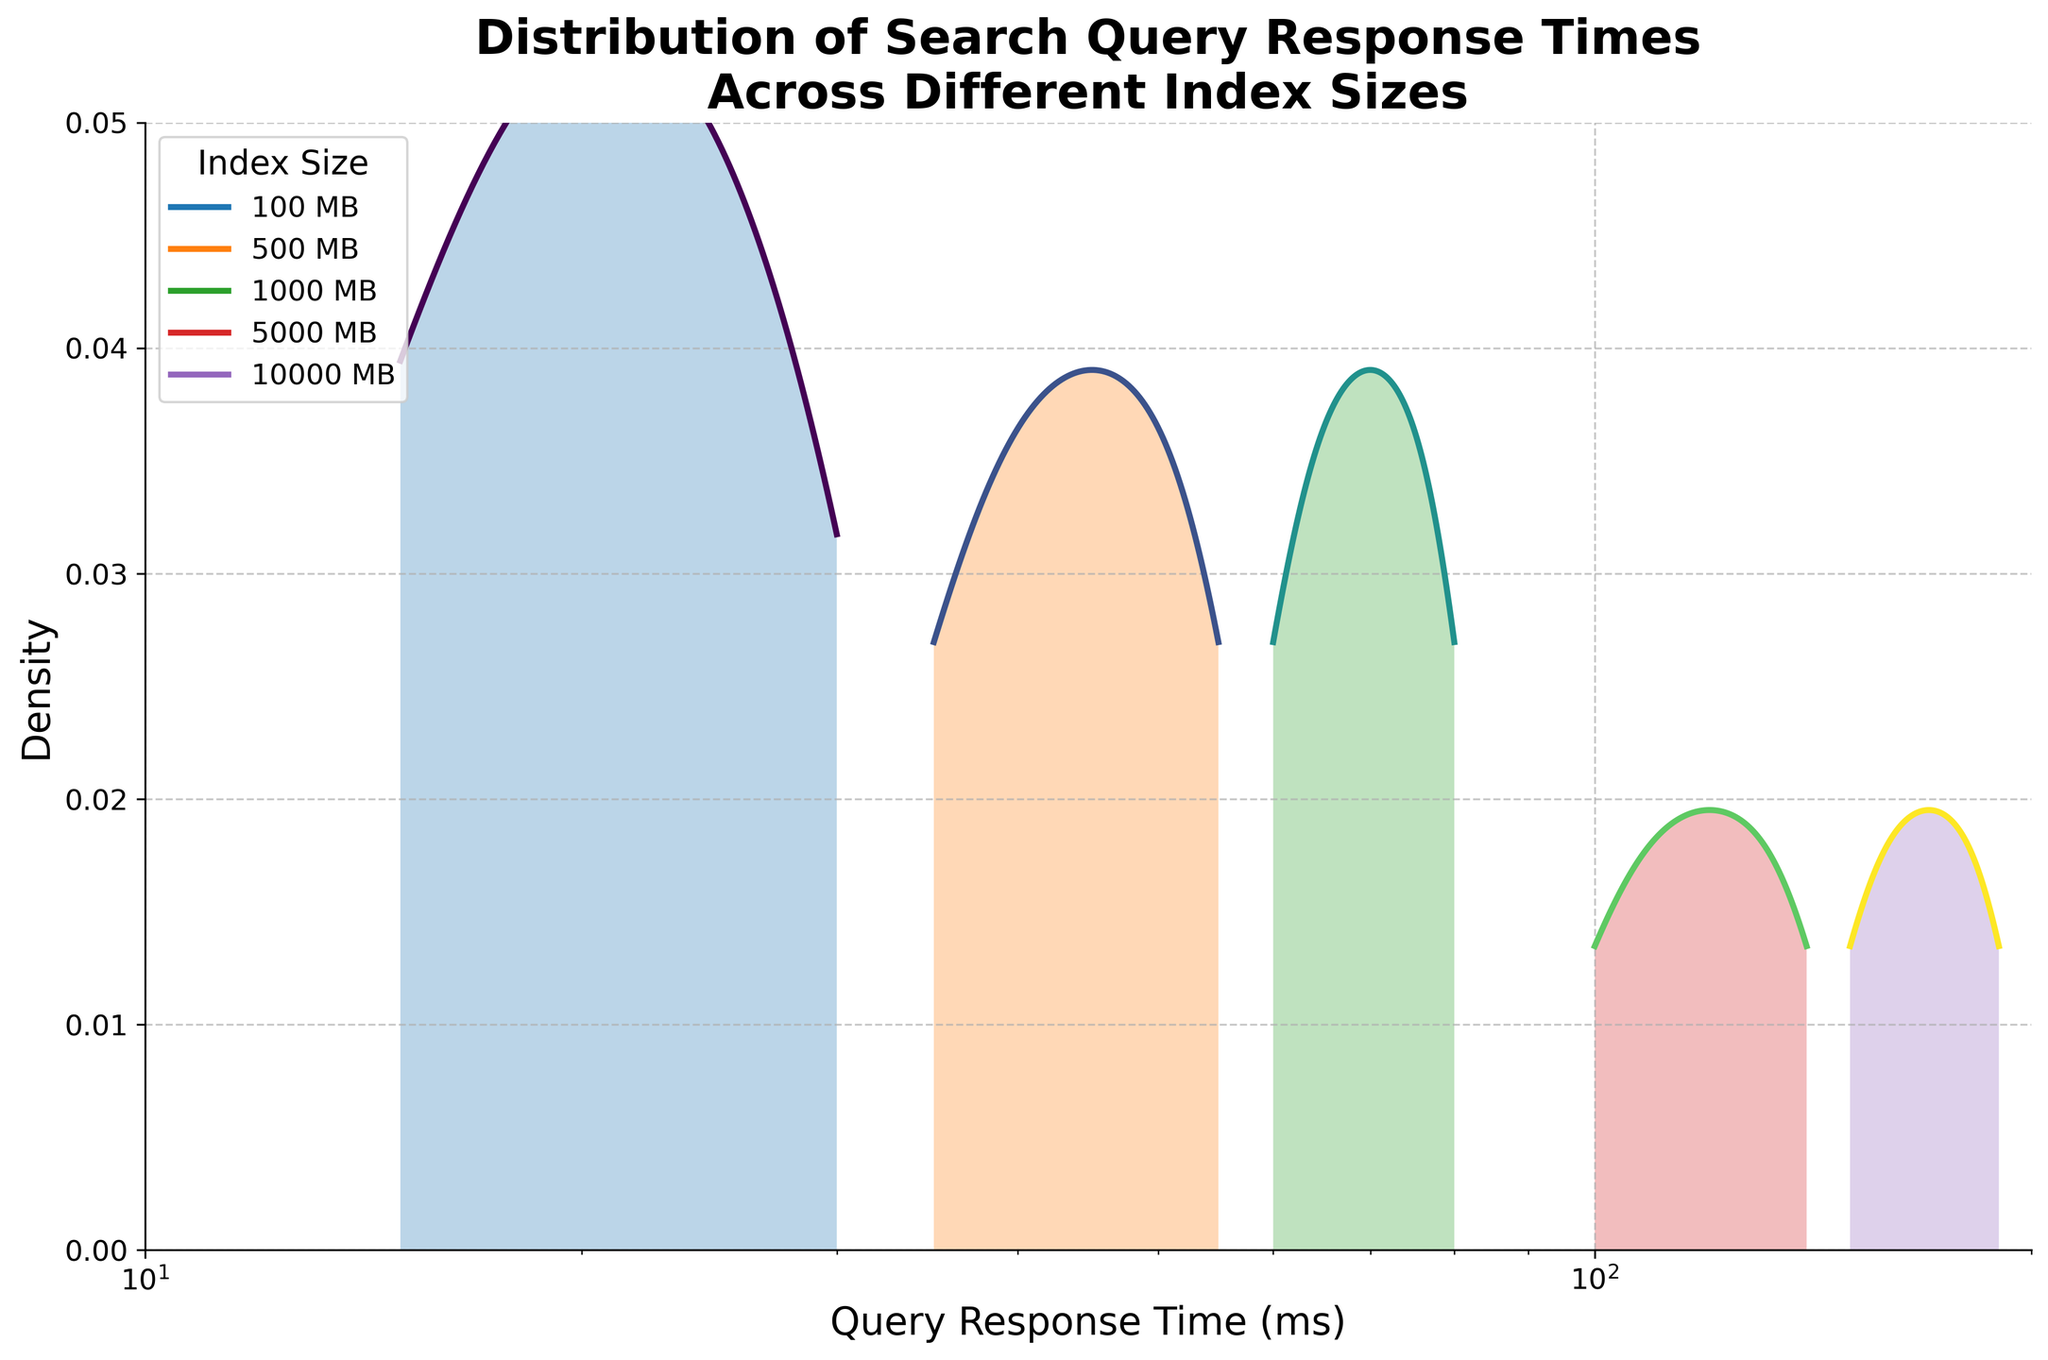What is the title of the density plot? The title is prominently displayed at the top of the density plot and reads "Distribution of Search Query Response Times Across Different Index Sizes."
Answer: Distribution of Search Query Response Times Across Different Index Sizes What is the range of the x-axis? The x-axis range can be observed from the minimum and maximum values shown, which are 10 and 200 respectively.
Answer: 10 to 200 Which index size has the highest density peak? By analyzing the plotted density lines, the 100 MB index size has the highest peak within the range of query response times.
Answer: 100 MB What happens to the density peaks as the index size increases? Observing the density plot, you can see that as the index size increases, the density peaks shift to higher response times, indicating that larger indexes generally have higher response times.
Answer: Peaks shift to higher response times What type of scale is used on the x-axis? The x-axis employs a logarithmic scale, evident from the manner in which the tick marks are spaced and labeled.
Answer: Logarithmic scale Which index size has the widest range of query response times? From observing the spread of the density lines, the 10000 MB index size shows the widest range of query response times.
Answer: 10000 MB Between which two index sizes does the largest increase in query response time density occur? By visually comparing the density plots, a notable increase is observed between the 5000 MB and 10000 MB index sizes.
Answer: 5000 MB and 10000 MB Is there any point where the densities of different index sizes overlap? Analyzing the filled density areas, there is no significant overlapping of densities among different index sizes, indicating distinct response times for different index sizes.
Answer: No What does the y-axis represent? The y-axis represents the density of query response times, as suggested by the title of the plot and the axis label "Density."
Answer: Density How do the densities compare between 500 MB and 1000 MB index sizes at their respective peaks? The peak density for 500 MB is higher compared to the peak density for the 1000 MB index size, which is visibly lower.
Answer: 500 MB has a higher peak 